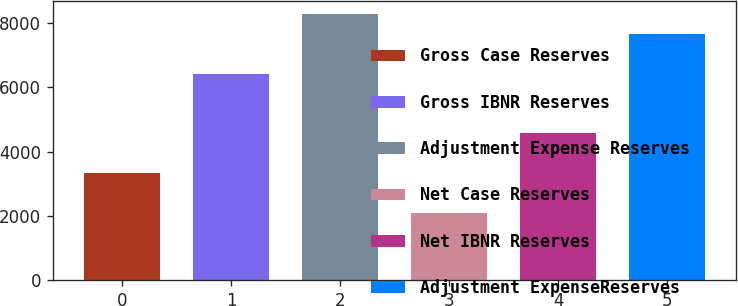Convert chart. <chart><loc_0><loc_0><loc_500><loc_500><bar_chart><fcel>Gross Case Reserves<fcel>Gross IBNR Reserves<fcel>Adjustment Expense Reserves<fcel>Net Case Reserves<fcel>Net IBNR Reserves<fcel>Adjustment ExpenseReserves<nl><fcel>3328.4<fcel>6424.4<fcel>8282<fcel>2090<fcel>4566.8<fcel>7662.8<nl></chart> 